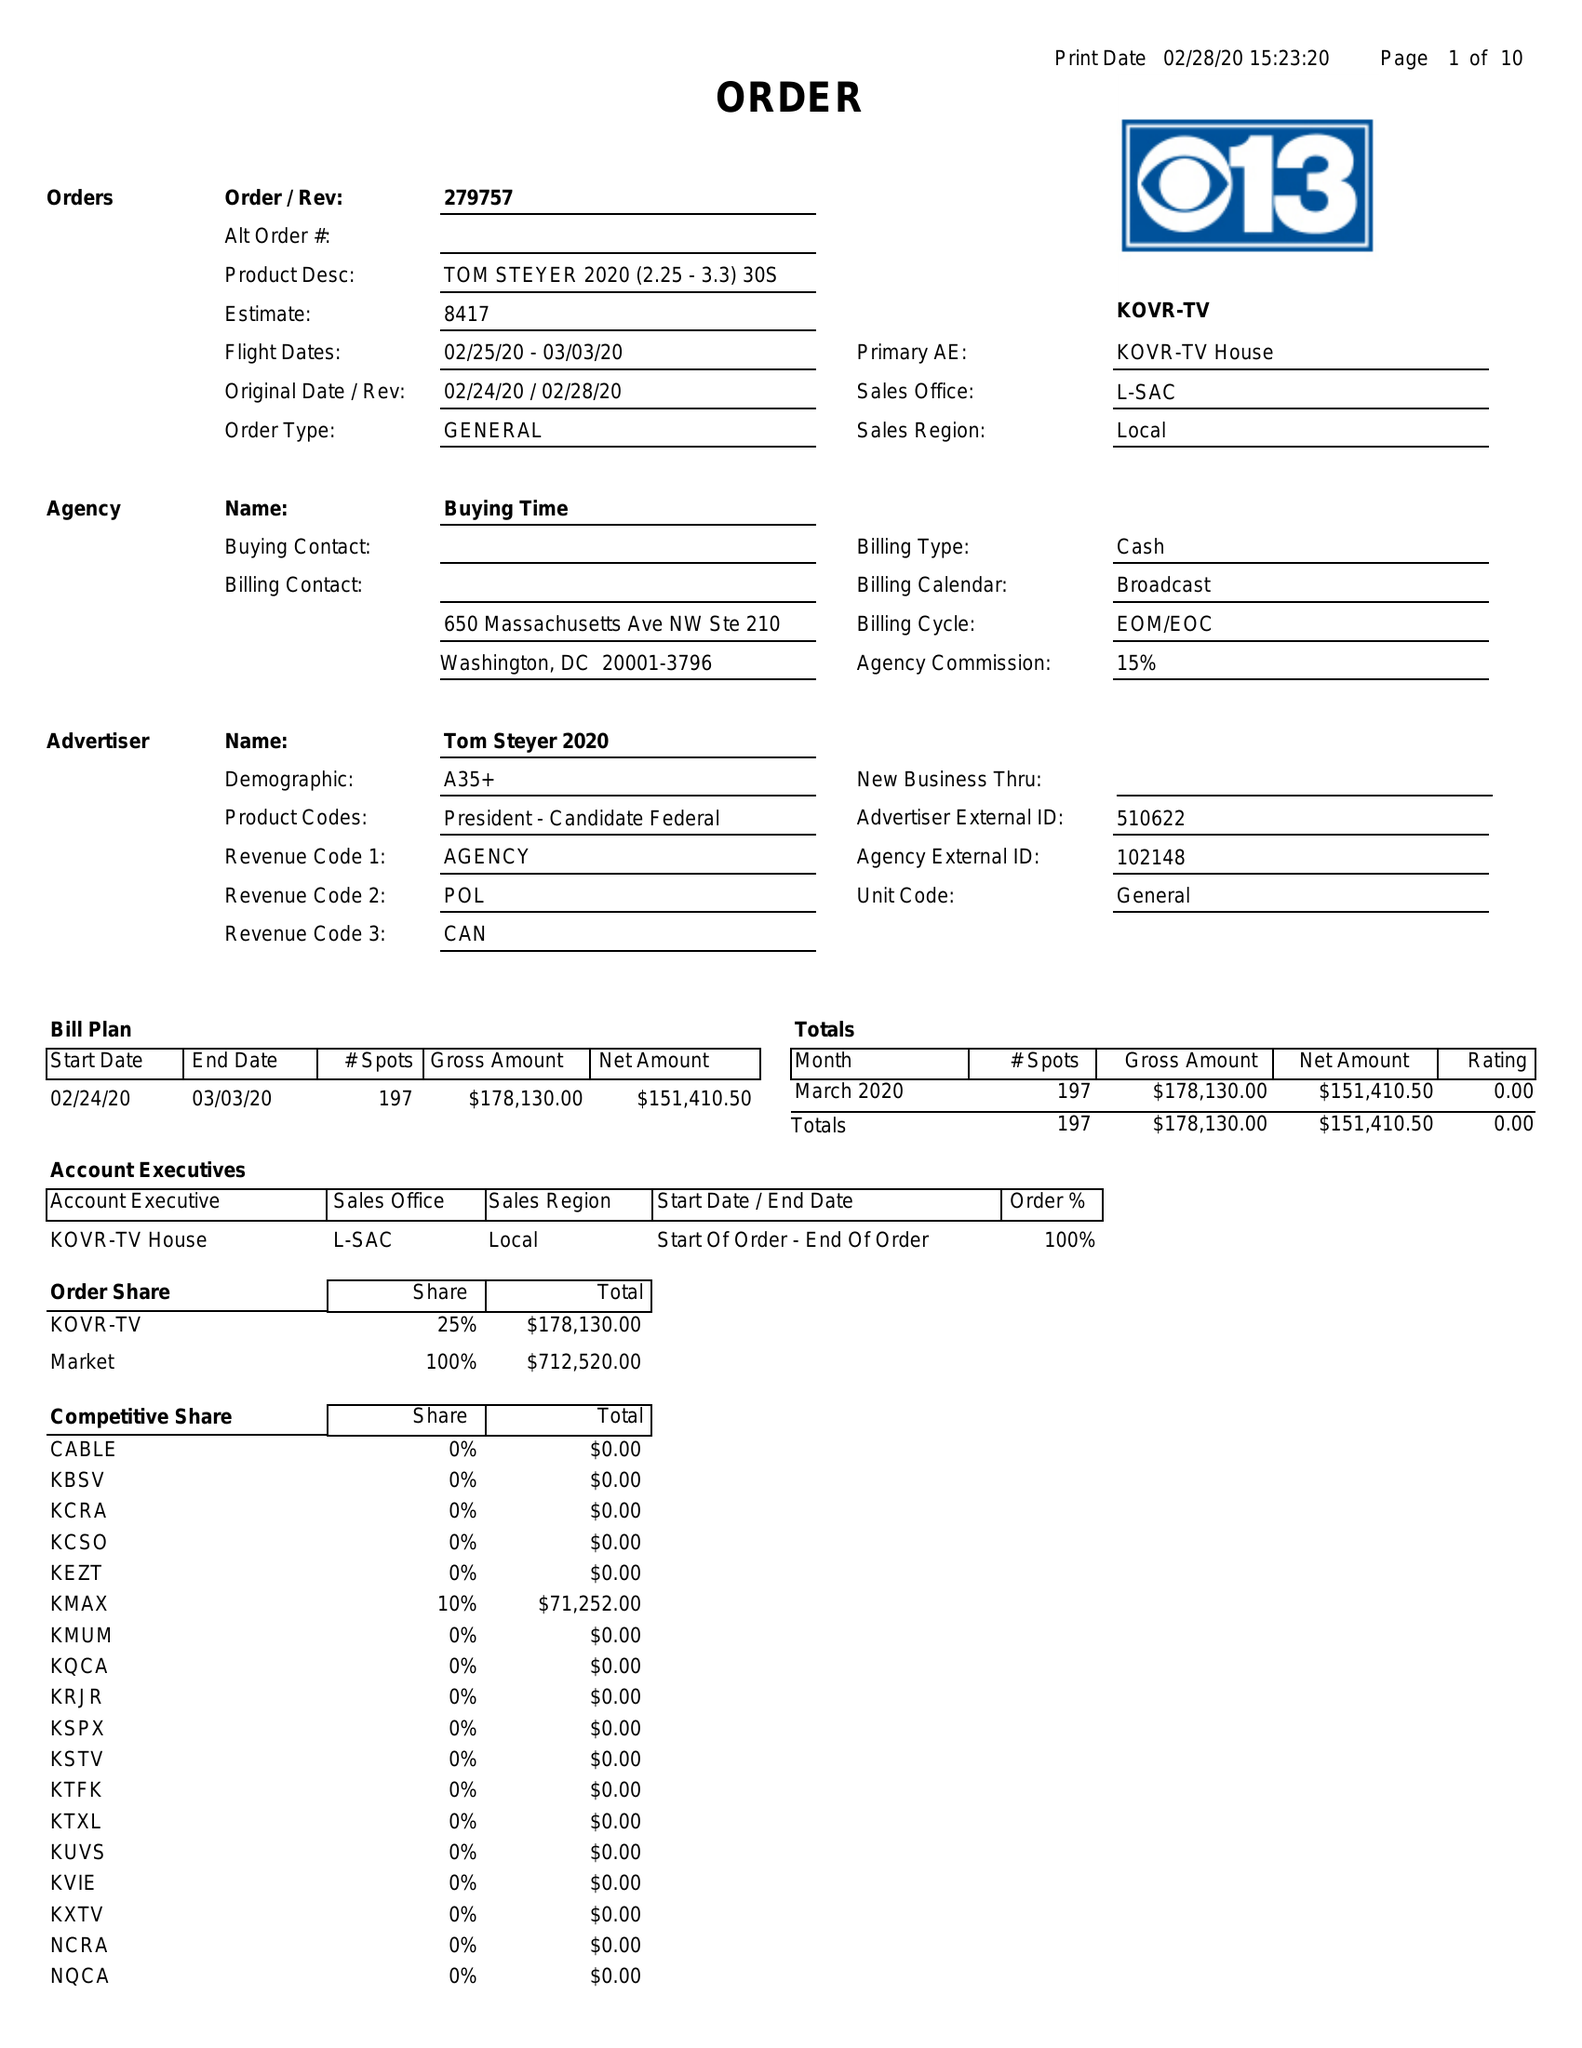What is the value for the advertiser?
Answer the question using a single word or phrase. TOM STEYER 2020 